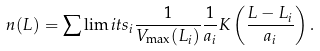<formula> <loc_0><loc_0><loc_500><loc_500>n ( L ) = \sum \lim i t s _ { i } \frac { 1 } { V _ { \max } ( L _ { i } ) } \frac { 1 } { a _ { i } } K \left ( \frac { L - L _ { i } } { a _ { i } } \right ) .</formula> 